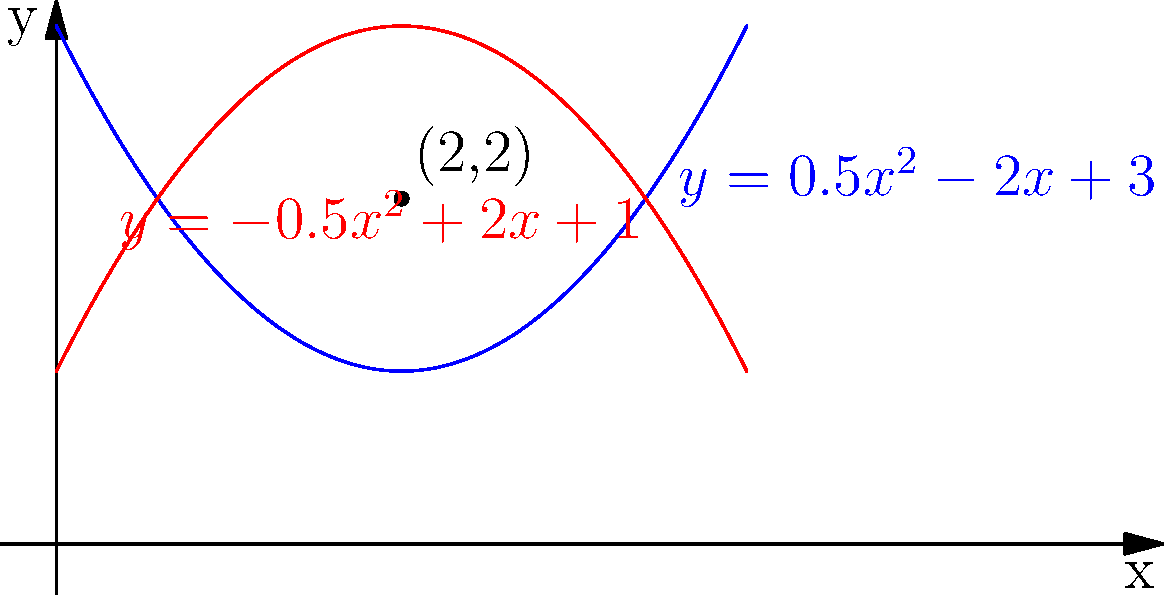As a sales representative promoting the latest sewing machine models, you're explaining a new feature that optimizes decorative stitch patterns. The machine can create patterns based on the area between two curves. For a specific design, the upper curve is given by $y = 0.5x^2 - 2x + 3$ and the lower curve by $y = -0.5x^2 + 2x + 1$. What is the maximum width of the stitch pattern, and at which x-coordinate does it occur? To find the maximum width of the stitch pattern, we need to determine the maximum vertical distance between the two curves.

Step 1: Express the vertical distance as a function of x.
$d(x) = (0.5x^2 - 2x + 3) - (-0.5x^2 + 2x + 1)$
$d(x) = x^2 - 4x + 2$

Step 2: To find the maximum, we need to find where the derivative of d(x) is zero.
$d'(x) = 2x - 4$

Step 3: Set d'(x) = 0 and solve for x.
$2x - 4 = 0$
$2x = 4$
$x = 2$

Step 4: Verify this is a maximum by checking the second derivative.
$d''(x) = 2 > 0$, so x = 2 gives a maximum.

Step 5: Calculate the maximum width by evaluating d(2).
$d(2) = 2^2 - 4(2) + 2 = 4 - 8 + 2 = -2$

The negative sign indicates the direction, but we're interested in the absolute width.

Therefore, the maximum width is 2 units, occurring at x = 2.
Answer: Maximum width: 2 units; x-coordinate: 2 